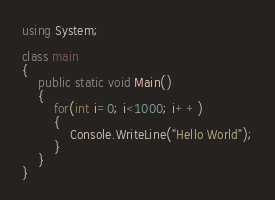<code> <loc_0><loc_0><loc_500><loc_500><_C#_>using System;

class main
{
	public static void Main()
	{
		for(int i=0; i<1000; i++)
		{
			Console.WriteLine("Hello World");
		}
	}
}</code> 